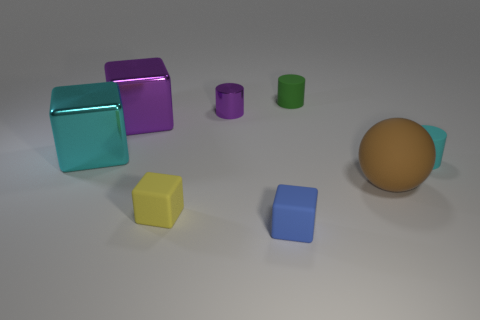Add 1 large blocks. How many objects exist? 9 Subtract all spheres. How many objects are left? 7 Add 4 red rubber spheres. How many red rubber spheres exist? 4 Subtract 1 green cylinders. How many objects are left? 7 Subtract all shiny objects. Subtract all big metallic cubes. How many objects are left? 3 Add 3 cyan cubes. How many cyan cubes are left? 4 